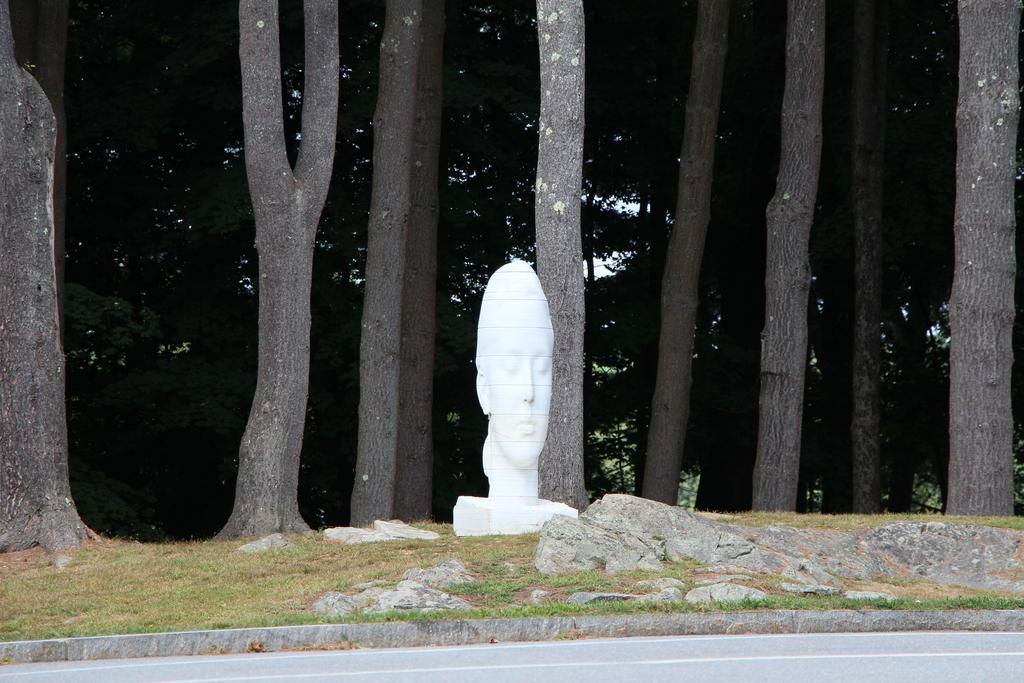Describe this image in one or two sentences. In the foreground of the picture we can see grass, rocks, road and a sculpture. In the background there are trees. 